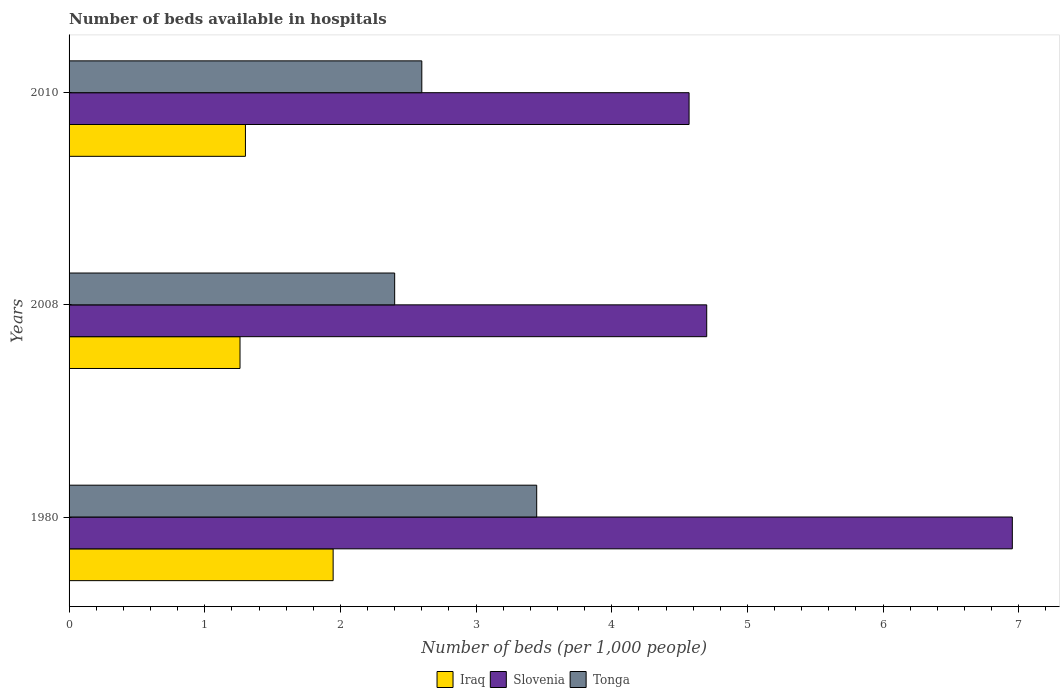How many different coloured bars are there?
Your answer should be very brief. 3. How many bars are there on the 1st tick from the bottom?
Your answer should be very brief. 3. In how many cases, is the number of bars for a given year not equal to the number of legend labels?
Provide a succinct answer. 0. What is the number of beds in the hospiatls of in Tonga in 2008?
Your response must be concise. 2.4. Across all years, what is the maximum number of beds in the hospiatls of in Tonga?
Make the answer very short. 3.45. Across all years, what is the minimum number of beds in the hospiatls of in Iraq?
Give a very brief answer. 1.26. What is the total number of beds in the hospiatls of in Iraq in the graph?
Make the answer very short. 4.51. What is the difference between the number of beds in the hospiatls of in Slovenia in 1980 and that in 2008?
Offer a terse response. 2.25. What is the difference between the number of beds in the hospiatls of in Slovenia in 2010 and the number of beds in the hospiatls of in Tonga in 2008?
Offer a terse response. 2.17. What is the average number of beds in the hospiatls of in Iraq per year?
Provide a succinct answer. 1.5. In the year 1980, what is the difference between the number of beds in the hospiatls of in Tonga and number of beds in the hospiatls of in Iraq?
Make the answer very short. 1.5. What is the ratio of the number of beds in the hospiatls of in Slovenia in 1980 to that in 2010?
Offer a terse response. 1.52. Is the difference between the number of beds in the hospiatls of in Tonga in 1980 and 2008 greater than the difference between the number of beds in the hospiatls of in Iraq in 1980 and 2008?
Keep it short and to the point. Yes. What is the difference between the highest and the second highest number of beds in the hospiatls of in Slovenia?
Give a very brief answer. 2.25. What is the difference between the highest and the lowest number of beds in the hospiatls of in Iraq?
Make the answer very short. 0.69. Is the sum of the number of beds in the hospiatls of in Tonga in 1980 and 2008 greater than the maximum number of beds in the hospiatls of in Iraq across all years?
Provide a short and direct response. Yes. What does the 2nd bar from the top in 1980 represents?
Your answer should be compact. Slovenia. What does the 1st bar from the bottom in 2008 represents?
Your answer should be very brief. Iraq. How many bars are there?
Provide a short and direct response. 9. Are all the bars in the graph horizontal?
Make the answer very short. Yes. What is the difference between two consecutive major ticks on the X-axis?
Your answer should be very brief. 1. Are the values on the major ticks of X-axis written in scientific E-notation?
Provide a short and direct response. No. Does the graph contain any zero values?
Offer a terse response. No. Does the graph contain grids?
Offer a terse response. No. Where does the legend appear in the graph?
Your answer should be compact. Bottom center. How many legend labels are there?
Offer a terse response. 3. What is the title of the graph?
Ensure brevity in your answer.  Number of beds available in hospitals. Does "Poland" appear as one of the legend labels in the graph?
Keep it short and to the point. No. What is the label or title of the X-axis?
Keep it short and to the point. Number of beds (per 1,0 people). What is the label or title of the Y-axis?
Make the answer very short. Years. What is the Number of beds (per 1,000 people) in Iraq in 1980?
Keep it short and to the point. 1.95. What is the Number of beds (per 1,000 people) of Slovenia in 1980?
Offer a terse response. 6.95. What is the Number of beds (per 1,000 people) in Tonga in 1980?
Offer a very short reply. 3.45. What is the Number of beds (per 1,000 people) of Iraq in 2008?
Offer a terse response. 1.26. What is the Number of beds (per 1,000 people) in Slovenia in 2008?
Your answer should be compact. 4.7. What is the Number of beds (per 1,000 people) of Slovenia in 2010?
Ensure brevity in your answer.  4.57. Across all years, what is the maximum Number of beds (per 1,000 people) in Iraq?
Your answer should be very brief. 1.95. Across all years, what is the maximum Number of beds (per 1,000 people) in Slovenia?
Provide a short and direct response. 6.95. Across all years, what is the maximum Number of beds (per 1,000 people) of Tonga?
Offer a very short reply. 3.45. Across all years, what is the minimum Number of beds (per 1,000 people) in Iraq?
Keep it short and to the point. 1.26. Across all years, what is the minimum Number of beds (per 1,000 people) of Slovenia?
Make the answer very short. 4.57. Across all years, what is the minimum Number of beds (per 1,000 people) in Tonga?
Offer a terse response. 2.4. What is the total Number of beds (per 1,000 people) of Iraq in the graph?
Make the answer very short. 4.51. What is the total Number of beds (per 1,000 people) in Slovenia in the graph?
Keep it short and to the point. 16.22. What is the total Number of beds (per 1,000 people) in Tonga in the graph?
Your response must be concise. 8.45. What is the difference between the Number of beds (per 1,000 people) of Iraq in 1980 and that in 2008?
Provide a short and direct response. 0.69. What is the difference between the Number of beds (per 1,000 people) of Slovenia in 1980 and that in 2008?
Make the answer very short. 2.25. What is the difference between the Number of beds (per 1,000 people) of Tonga in 1980 and that in 2008?
Your answer should be very brief. 1.05. What is the difference between the Number of beds (per 1,000 people) in Iraq in 1980 and that in 2010?
Offer a terse response. 0.65. What is the difference between the Number of beds (per 1,000 people) of Slovenia in 1980 and that in 2010?
Keep it short and to the point. 2.38. What is the difference between the Number of beds (per 1,000 people) in Tonga in 1980 and that in 2010?
Ensure brevity in your answer.  0.85. What is the difference between the Number of beds (per 1,000 people) of Iraq in 2008 and that in 2010?
Ensure brevity in your answer.  -0.04. What is the difference between the Number of beds (per 1,000 people) of Slovenia in 2008 and that in 2010?
Your answer should be compact. 0.13. What is the difference between the Number of beds (per 1,000 people) of Iraq in 1980 and the Number of beds (per 1,000 people) of Slovenia in 2008?
Give a very brief answer. -2.75. What is the difference between the Number of beds (per 1,000 people) in Iraq in 1980 and the Number of beds (per 1,000 people) in Tonga in 2008?
Offer a terse response. -0.45. What is the difference between the Number of beds (per 1,000 people) in Slovenia in 1980 and the Number of beds (per 1,000 people) in Tonga in 2008?
Offer a terse response. 4.55. What is the difference between the Number of beds (per 1,000 people) of Iraq in 1980 and the Number of beds (per 1,000 people) of Slovenia in 2010?
Provide a succinct answer. -2.62. What is the difference between the Number of beds (per 1,000 people) of Iraq in 1980 and the Number of beds (per 1,000 people) of Tonga in 2010?
Make the answer very short. -0.65. What is the difference between the Number of beds (per 1,000 people) in Slovenia in 1980 and the Number of beds (per 1,000 people) in Tonga in 2010?
Make the answer very short. 4.35. What is the difference between the Number of beds (per 1,000 people) in Iraq in 2008 and the Number of beds (per 1,000 people) in Slovenia in 2010?
Offer a very short reply. -3.31. What is the difference between the Number of beds (per 1,000 people) of Iraq in 2008 and the Number of beds (per 1,000 people) of Tonga in 2010?
Offer a very short reply. -1.34. What is the difference between the Number of beds (per 1,000 people) of Slovenia in 2008 and the Number of beds (per 1,000 people) of Tonga in 2010?
Your answer should be very brief. 2.1. What is the average Number of beds (per 1,000 people) of Iraq per year?
Your answer should be compact. 1.5. What is the average Number of beds (per 1,000 people) in Slovenia per year?
Ensure brevity in your answer.  5.41. What is the average Number of beds (per 1,000 people) of Tonga per year?
Ensure brevity in your answer.  2.82. In the year 1980, what is the difference between the Number of beds (per 1,000 people) of Iraq and Number of beds (per 1,000 people) of Slovenia?
Your response must be concise. -5.01. In the year 1980, what is the difference between the Number of beds (per 1,000 people) of Iraq and Number of beds (per 1,000 people) of Tonga?
Provide a short and direct response. -1.5. In the year 1980, what is the difference between the Number of beds (per 1,000 people) in Slovenia and Number of beds (per 1,000 people) in Tonga?
Ensure brevity in your answer.  3.51. In the year 2008, what is the difference between the Number of beds (per 1,000 people) of Iraq and Number of beds (per 1,000 people) of Slovenia?
Your response must be concise. -3.44. In the year 2008, what is the difference between the Number of beds (per 1,000 people) of Iraq and Number of beds (per 1,000 people) of Tonga?
Provide a succinct answer. -1.14. In the year 2008, what is the difference between the Number of beds (per 1,000 people) in Slovenia and Number of beds (per 1,000 people) in Tonga?
Provide a short and direct response. 2.3. In the year 2010, what is the difference between the Number of beds (per 1,000 people) in Iraq and Number of beds (per 1,000 people) in Slovenia?
Provide a succinct answer. -3.27. In the year 2010, what is the difference between the Number of beds (per 1,000 people) in Slovenia and Number of beds (per 1,000 people) in Tonga?
Make the answer very short. 1.97. What is the ratio of the Number of beds (per 1,000 people) in Iraq in 1980 to that in 2008?
Keep it short and to the point. 1.54. What is the ratio of the Number of beds (per 1,000 people) of Slovenia in 1980 to that in 2008?
Give a very brief answer. 1.48. What is the ratio of the Number of beds (per 1,000 people) of Tonga in 1980 to that in 2008?
Provide a succinct answer. 1.44. What is the ratio of the Number of beds (per 1,000 people) in Iraq in 1980 to that in 2010?
Your answer should be very brief. 1.5. What is the ratio of the Number of beds (per 1,000 people) of Slovenia in 1980 to that in 2010?
Give a very brief answer. 1.52. What is the ratio of the Number of beds (per 1,000 people) of Tonga in 1980 to that in 2010?
Provide a succinct answer. 1.33. What is the ratio of the Number of beds (per 1,000 people) in Iraq in 2008 to that in 2010?
Provide a short and direct response. 0.97. What is the ratio of the Number of beds (per 1,000 people) in Slovenia in 2008 to that in 2010?
Provide a succinct answer. 1.03. What is the difference between the highest and the second highest Number of beds (per 1,000 people) in Iraq?
Provide a short and direct response. 0.65. What is the difference between the highest and the second highest Number of beds (per 1,000 people) in Slovenia?
Your answer should be very brief. 2.25. What is the difference between the highest and the second highest Number of beds (per 1,000 people) in Tonga?
Keep it short and to the point. 0.85. What is the difference between the highest and the lowest Number of beds (per 1,000 people) of Iraq?
Keep it short and to the point. 0.69. What is the difference between the highest and the lowest Number of beds (per 1,000 people) in Slovenia?
Your answer should be very brief. 2.38. What is the difference between the highest and the lowest Number of beds (per 1,000 people) of Tonga?
Give a very brief answer. 1.05. 